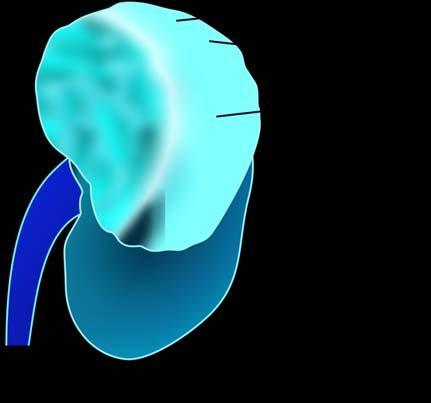does mucicarmine show a large and tan mass while rest of the kidney has reniform contour?
Answer the question using a single word or phrase. No 